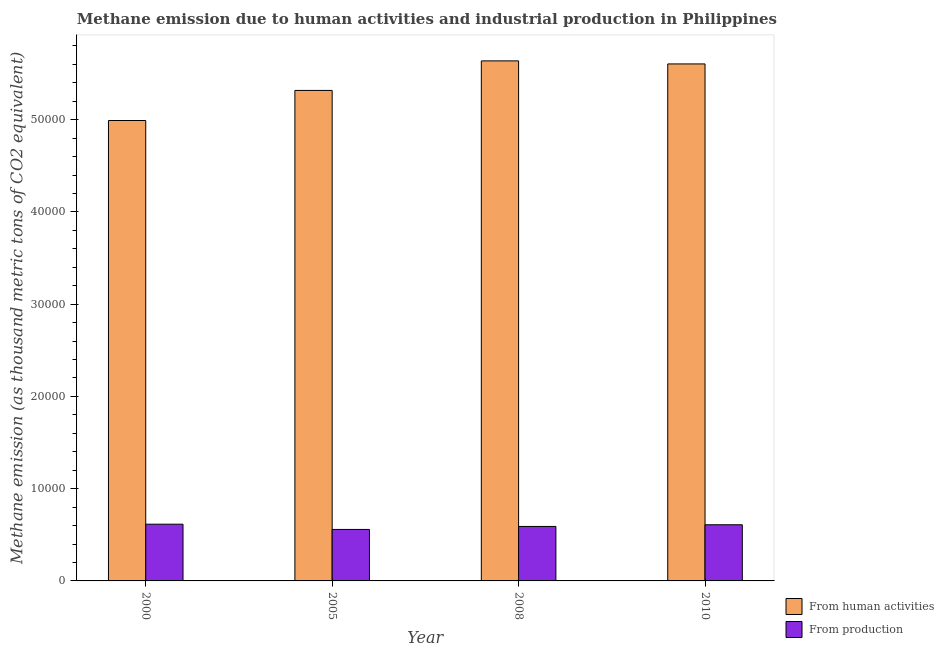Are the number of bars on each tick of the X-axis equal?
Offer a very short reply. Yes. How many bars are there on the 4th tick from the left?
Offer a terse response. 2. How many bars are there on the 4th tick from the right?
Ensure brevity in your answer.  2. What is the label of the 1st group of bars from the left?
Ensure brevity in your answer.  2000. In how many cases, is the number of bars for a given year not equal to the number of legend labels?
Your response must be concise. 0. What is the amount of emissions generated from industries in 2010?
Provide a short and direct response. 6088.8. Across all years, what is the maximum amount of emissions generated from industries?
Provide a short and direct response. 6149.1. Across all years, what is the minimum amount of emissions generated from industries?
Offer a terse response. 5580.9. In which year was the amount of emissions from human activities minimum?
Provide a succinct answer. 2000. What is the total amount of emissions from human activities in the graph?
Your response must be concise. 2.16e+05. What is the difference between the amount of emissions generated from industries in 2000 and that in 2008?
Make the answer very short. 243.2. What is the difference between the amount of emissions from human activities in 2000 and the amount of emissions generated from industries in 2008?
Your answer should be very brief. -6464.7. What is the average amount of emissions from human activities per year?
Give a very brief answer. 5.39e+04. In the year 2010, what is the difference between the amount of emissions from human activities and amount of emissions generated from industries?
Offer a very short reply. 0. In how many years, is the amount of emissions from human activities greater than 24000 thousand metric tons?
Provide a succinct answer. 4. What is the ratio of the amount of emissions from human activities in 2005 to that in 2008?
Offer a very short reply. 0.94. Is the amount of emissions from human activities in 2000 less than that in 2005?
Ensure brevity in your answer.  Yes. What is the difference between the highest and the second highest amount of emissions from human activities?
Offer a very short reply. 330.4. What is the difference between the highest and the lowest amount of emissions from human activities?
Your answer should be very brief. 6464.7. What does the 1st bar from the left in 2000 represents?
Ensure brevity in your answer.  From human activities. What does the 2nd bar from the right in 2008 represents?
Offer a very short reply. From human activities. How many bars are there?
Keep it short and to the point. 8. What is the difference between two consecutive major ticks on the Y-axis?
Your response must be concise. 10000. Are the values on the major ticks of Y-axis written in scientific E-notation?
Make the answer very short. No. Does the graph contain grids?
Your response must be concise. No. Where does the legend appear in the graph?
Offer a terse response. Bottom right. What is the title of the graph?
Keep it short and to the point. Methane emission due to human activities and industrial production in Philippines. What is the label or title of the X-axis?
Your response must be concise. Year. What is the label or title of the Y-axis?
Your answer should be very brief. Methane emission (as thousand metric tons of CO2 equivalent). What is the Methane emission (as thousand metric tons of CO2 equivalent) of From human activities in 2000?
Your response must be concise. 4.99e+04. What is the Methane emission (as thousand metric tons of CO2 equivalent) of From production in 2000?
Your response must be concise. 6149.1. What is the Methane emission (as thousand metric tons of CO2 equivalent) in From human activities in 2005?
Ensure brevity in your answer.  5.32e+04. What is the Methane emission (as thousand metric tons of CO2 equivalent) of From production in 2005?
Your response must be concise. 5580.9. What is the Methane emission (as thousand metric tons of CO2 equivalent) in From human activities in 2008?
Your answer should be compact. 5.64e+04. What is the Methane emission (as thousand metric tons of CO2 equivalent) of From production in 2008?
Provide a succinct answer. 5905.9. What is the Methane emission (as thousand metric tons of CO2 equivalent) of From human activities in 2010?
Offer a very short reply. 5.60e+04. What is the Methane emission (as thousand metric tons of CO2 equivalent) of From production in 2010?
Your response must be concise. 6088.8. Across all years, what is the maximum Methane emission (as thousand metric tons of CO2 equivalent) of From human activities?
Ensure brevity in your answer.  5.64e+04. Across all years, what is the maximum Methane emission (as thousand metric tons of CO2 equivalent) of From production?
Your response must be concise. 6149.1. Across all years, what is the minimum Methane emission (as thousand metric tons of CO2 equivalent) in From human activities?
Provide a succinct answer. 4.99e+04. Across all years, what is the minimum Methane emission (as thousand metric tons of CO2 equivalent) of From production?
Offer a terse response. 5580.9. What is the total Methane emission (as thousand metric tons of CO2 equivalent) of From human activities in the graph?
Your response must be concise. 2.16e+05. What is the total Methane emission (as thousand metric tons of CO2 equivalent) of From production in the graph?
Offer a very short reply. 2.37e+04. What is the difference between the Methane emission (as thousand metric tons of CO2 equivalent) in From human activities in 2000 and that in 2005?
Make the answer very short. -3260.6. What is the difference between the Methane emission (as thousand metric tons of CO2 equivalent) in From production in 2000 and that in 2005?
Make the answer very short. 568.2. What is the difference between the Methane emission (as thousand metric tons of CO2 equivalent) in From human activities in 2000 and that in 2008?
Your response must be concise. -6464.7. What is the difference between the Methane emission (as thousand metric tons of CO2 equivalent) in From production in 2000 and that in 2008?
Your answer should be very brief. 243.2. What is the difference between the Methane emission (as thousand metric tons of CO2 equivalent) in From human activities in 2000 and that in 2010?
Your answer should be compact. -6134.3. What is the difference between the Methane emission (as thousand metric tons of CO2 equivalent) in From production in 2000 and that in 2010?
Keep it short and to the point. 60.3. What is the difference between the Methane emission (as thousand metric tons of CO2 equivalent) of From human activities in 2005 and that in 2008?
Keep it short and to the point. -3204.1. What is the difference between the Methane emission (as thousand metric tons of CO2 equivalent) in From production in 2005 and that in 2008?
Your answer should be compact. -325. What is the difference between the Methane emission (as thousand metric tons of CO2 equivalent) in From human activities in 2005 and that in 2010?
Provide a short and direct response. -2873.7. What is the difference between the Methane emission (as thousand metric tons of CO2 equivalent) of From production in 2005 and that in 2010?
Your answer should be very brief. -507.9. What is the difference between the Methane emission (as thousand metric tons of CO2 equivalent) of From human activities in 2008 and that in 2010?
Make the answer very short. 330.4. What is the difference between the Methane emission (as thousand metric tons of CO2 equivalent) of From production in 2008 and that in 2010?
Your answer should be compact. -182.9. What is the difference between the Methane emission (as thousand metric tons of CO2 equivalent) of From human activities in 2000 and the Methane emission (as thousand metric tons of CO2 equivalent) of From production in 2005?
Your answer should be compact. 4.43e+04. What is the difference between the Methane emission (as thousand metric tons of CO2 equivalent) of From human activities in 2000 and the Methane emission (as thousand metric tons of CO2 equivalent) of From production in 2008?
Your response must be concise. 4.40e+04. What is the difference between the Methane emission (as thousand metric tons of CO2 equivalent) of From human activities in 2000 and the Methane emission (as thousand metric tons of CO2 equivalent) of From production in 2010?
Give a very brief answer. 4.38e+04. What is the difference between the Methane emission (as thousand metric tons of CO2 equivalent) of From human activities in 2005 and the Methane emission (as thousand metric tons of CO2 equivalent) of From production in 2008?
Keep it short and to the point. 4.73e+04. What is the difference between the Methane emission (as thousand metric tons of CO2 equivalent) in From human activities in 2005 and the Methane emission (as thousand metric tons of CO2 equivalent) in From production in 2010?
Give a very brief answer. 4.71e+04. What is the difference between the Methane emission (as thousand metric tons of CO2 equivalent) of From human activities in 2008 and the Methane emission (as thousand metric tons of CO2 equivalent) of From production in 2010?
Offer a very short reply. 5.03e+04. What is the average Methane emission (as thousand metric tons of CO2 equivalent) of From human activities per year?
Make the answer very short. 5.39e+04. What is the average Methane emission (as thousand metric tons of CO2 equivalent) of From production per year?
Keep it short and to the point. 5931.18. In the year 2000, what is the difference between the Methane emission (as thousand metric tons of CO2 equivalent) of From human activities and Methane emission (as thousand metric tons of CO2 equivalent) of From production?
Offer a very short reply. 4.38e+04. In the year 2005, what is the difference between the Methane emission (as thousand metric tons of CO2 equivalent) in From human activities and Methane emission (as thousand metric tons of CO2 equivalent) in From production?
Offer a very short reply. 4.76e+04. In the year 2008, what is the difference between the Methane emission (as thousand metric tons of CO2 equivalent) of From human activities and Methane emission (as thousand metric tons of CO2 equivalent) of From production?
Provide a short and direct response. 5.05e+04. In the year 2010, what is the difference between the Methane emission (as thousand metric tons of CO2 equivalent) in From human activities and Methane emission (as thousand metric tons of CO2 equivalent) in From production?
Provide a short and direct response. 5.00e+04. What is the ratio of the Methane emission (as thousand metric tons of CO2 equivalent) in From human activities in 2000 to that in 2005?
Provide a short and direct response. 0.94. What is the ratio of the Methane emission (as thousand metric tons of CO2 equivalent) of From production in 2000 to that in 2005?
Provide a succinct answer. 1.1. What is the ratio of the Methane emission (as thousand metric tons of CO2 equivalent) of From human activities in 2000 to that in 2008?
Your answer should be very brief. 0.89. What is the ratio of the Methane emission (as thousand metric tons of CO2 equivalent) in From production in 2000 to that in 2008?
Your response must be concise. 1.04. What is the ratio of the Methane emission (as thousand metric tons of CO2 equivalent) of From human activities in 2000 to that in 2010?
Your response must be concise. 0.89. What is the ratio of the Methane emission (as thousand metric tons of CO2 equivalent) in From production in 2000 to that in 2010?
Keep it short and to the point. 1.01. What is the ratio of the Methane emission (as thousand metric tons of CO2 equivalent) of From human activities in 2005 to that in 2008?
Keep it short and to the point. 0.94. What is the ratio of the Methane emission (as thousand metric tons of CO2 equivalent) in From production in 2005 to that in 2008?
Ensure brevity in your answer.  0.94. What is the ratio of the Methane emission (as thousand metric tons of CO2 equivalent) in From human activities in 2005 to that in 2010?
Keep it short and to the point. 0.95. What is the ratio of the Methane emission (as thousand metric tons of CO2 equivalent) in From production in 2005 to that in 2010?
Offer a very short reply. 0.92. What is the ratio of the Methane emission (as thousand metric tons of CO2 equivalent) of From human activities in 2008 to that in 2010?
Give a very brief answer. 1.01. What is the difference between the highest and the second highest Methane emission (as thousand metric tons of CO2 equivalent) of From human activities?
Your response must be concise. 330.4. What is the difference between the highest and the second highest Methane emission (as thousand metric tons of CO2 equivalent) in From production?
Provide a succinct answer. 60.3. What is the difference between the highest and the lowest Methane emission (as thousand metric tons of CO2 equivalent) of From human activities?
Your answer should be compact. 6464.7. What is the difference between the highest and the lowest Methane emission (as thousand metric tons of CO2 equivalent) in From production?
Give a very brief answer. 568.2. 